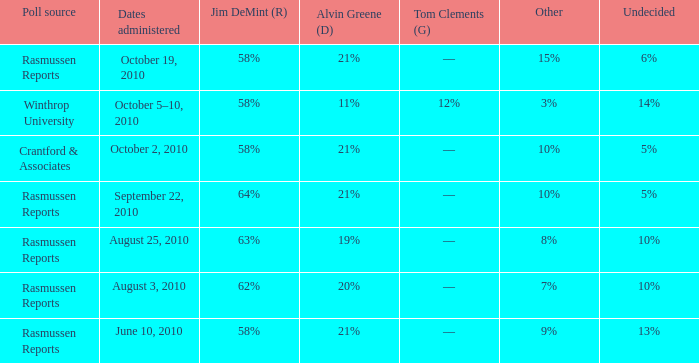What was the vote for Alvin Green when other was 9%? 21%. 